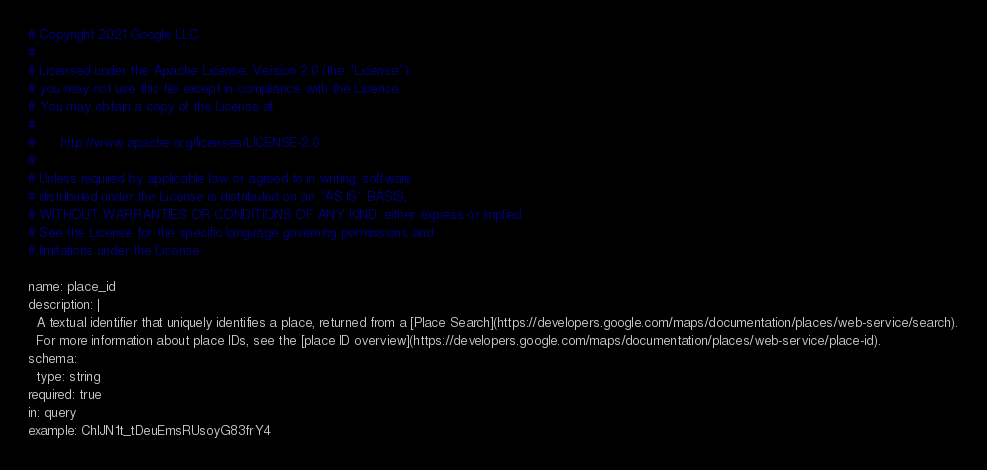Convert code to text. <code><loc_0><loc_0><loc_500><loc_500><_YAML_># Copyright 2021 Google LLC
#
# Licensed under the Apache License, Version 2.0 (the "License");
# you may not use this file except in compliance with the License.
# You may obtain a copy of the License at
#
#      http://www.apache.org/licenses/LICENSE-2.0
#
# Unless required by applicable law or agreed to in writing, software
# distributed under the License is distributed on an "AS IS" BASIS,
# WITHOUT WARRANTIES OR CONDITIONS OF ANY KIND, either express or implied.
# See the License for the specific language governing permissions and
# limitations under the License.

name: place_id    
description: |
  A textual identifier that uniquely identifies a place, returned from a [Place Search](https://developers.google.com/maps/documentation/places/web-service/search).
  For more information about place IDs, see the [place ID overview](https://developers.google.com/maps/documentation/places/web-service/place-id).
schema:
  type: string
required: true
in: query
example: ChIJN1t_tDeuEmsRUsoyG83frY4
</code> 